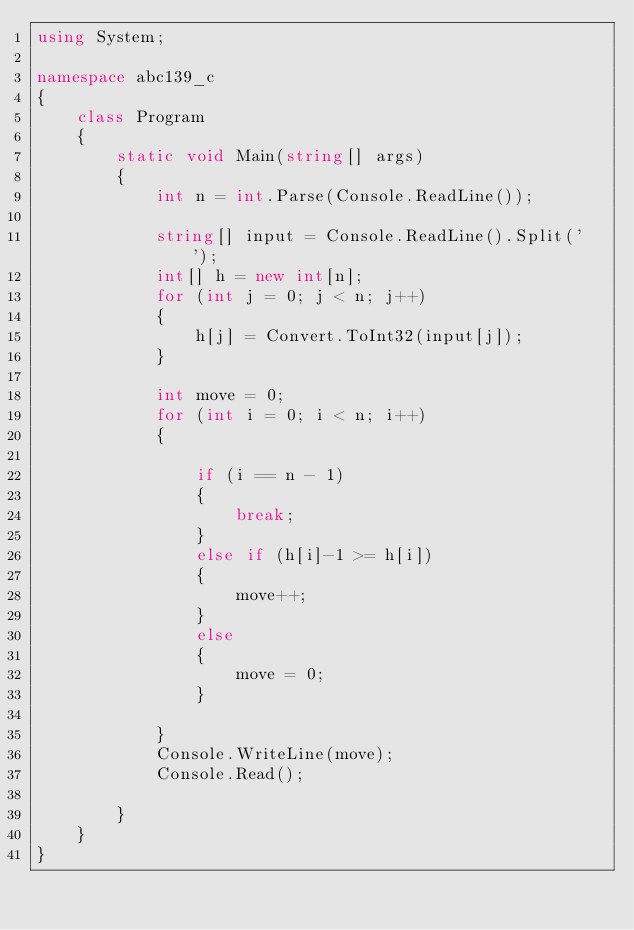Convert code to text. <code><loc_0><loc_0><loc_500><loc_500><_C#_>using System;

namespace abc139_c
{
    class Program
    {
        static void Main(string[] args)
        {
            int n = int.Parse(Console.ReadLine());

            string[] input = Console.ReadLine().Split(' ');
            int[] h = new int[n];
            for (int j = 0; j < n; j++)
            {
                h[j] = Convert.ToInt32(input[j]);
            }

            int move = 0;
            for (int i = 0; i < n; i++)
            {

                if (i == n - 1)
                {
                    break;
                }
                else if (h[i]-1 >= h[i])
                {
                    move++;
                }
                else
                {
                    move = 0;
                }

            }
            Console.WriteLine(move);
            Console.Read();

        }
    }
}
</code> 